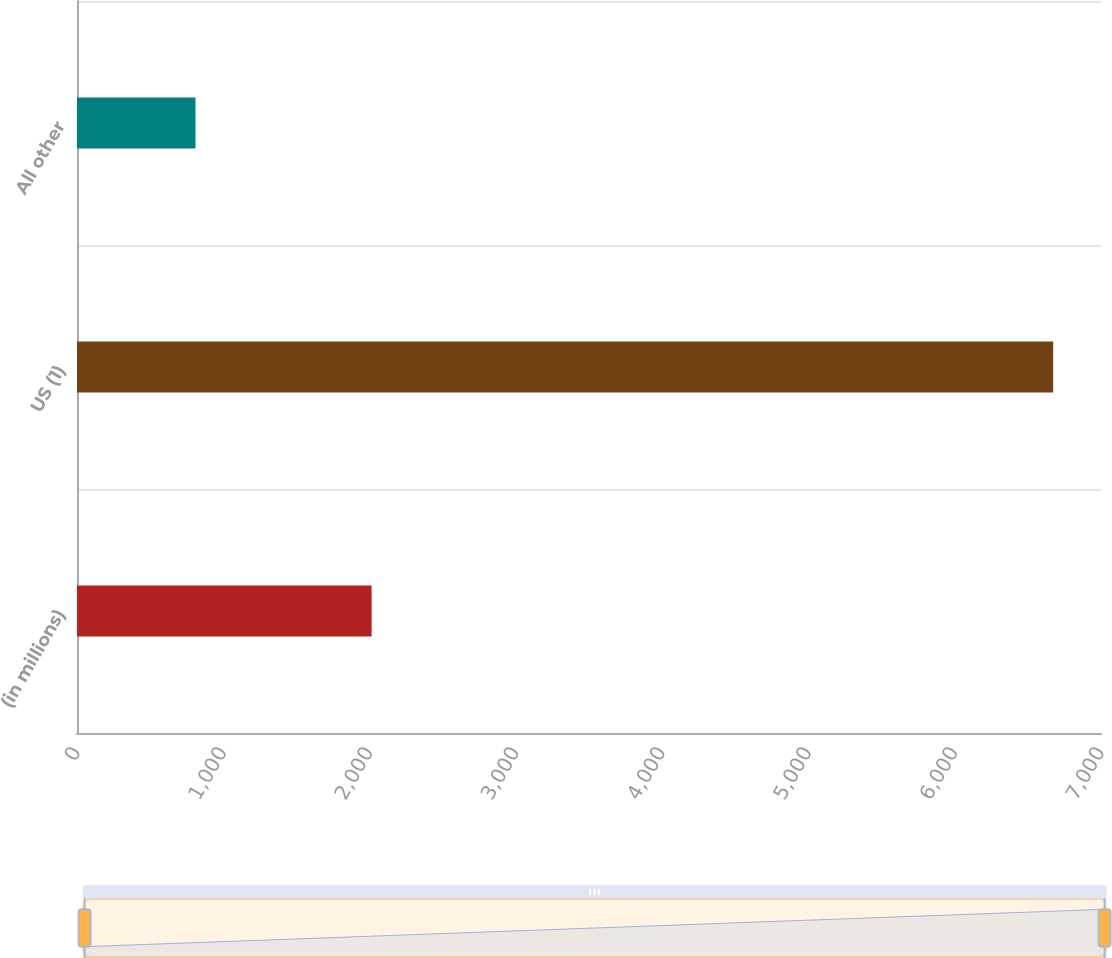<chart> <loc_0><loc_0><loc_500><loc_500><bar_chart><fcel>(in millions)<fcel>US (1)<fcel>All other<nl><fcel>2014<fcel>6673<fcel>810<nl></chart> 